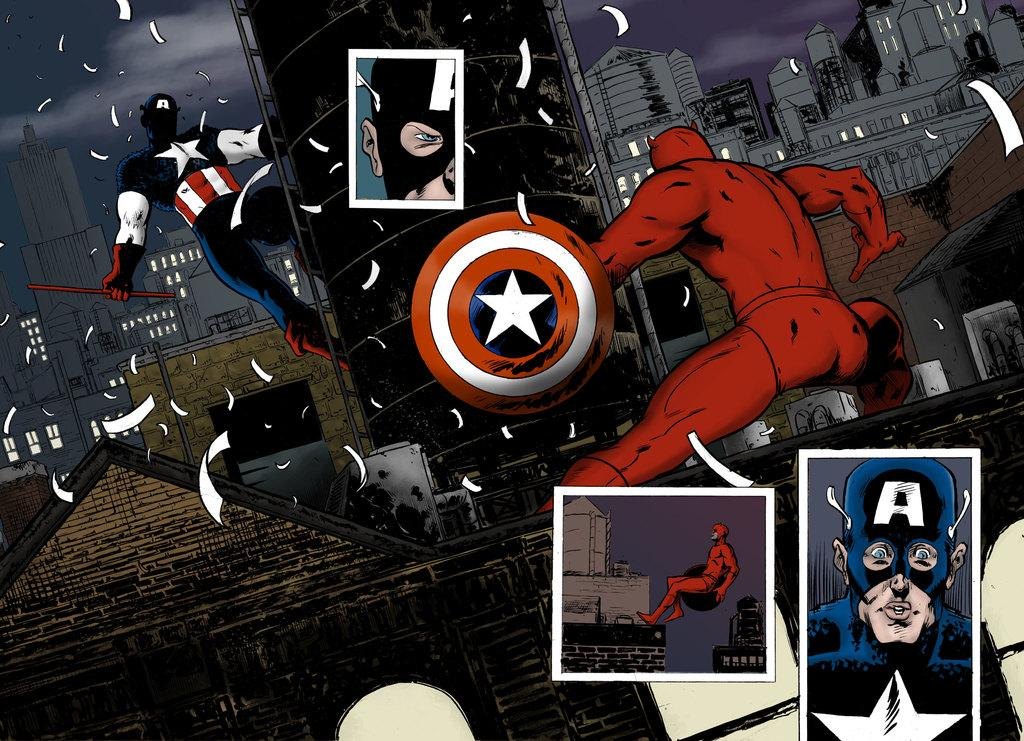What type of image is being described? The image is graphical. What type of flower is depicted in the graphical image? There is no flower, such as a rose, depicted in the image, as it is only described as being graphical. 